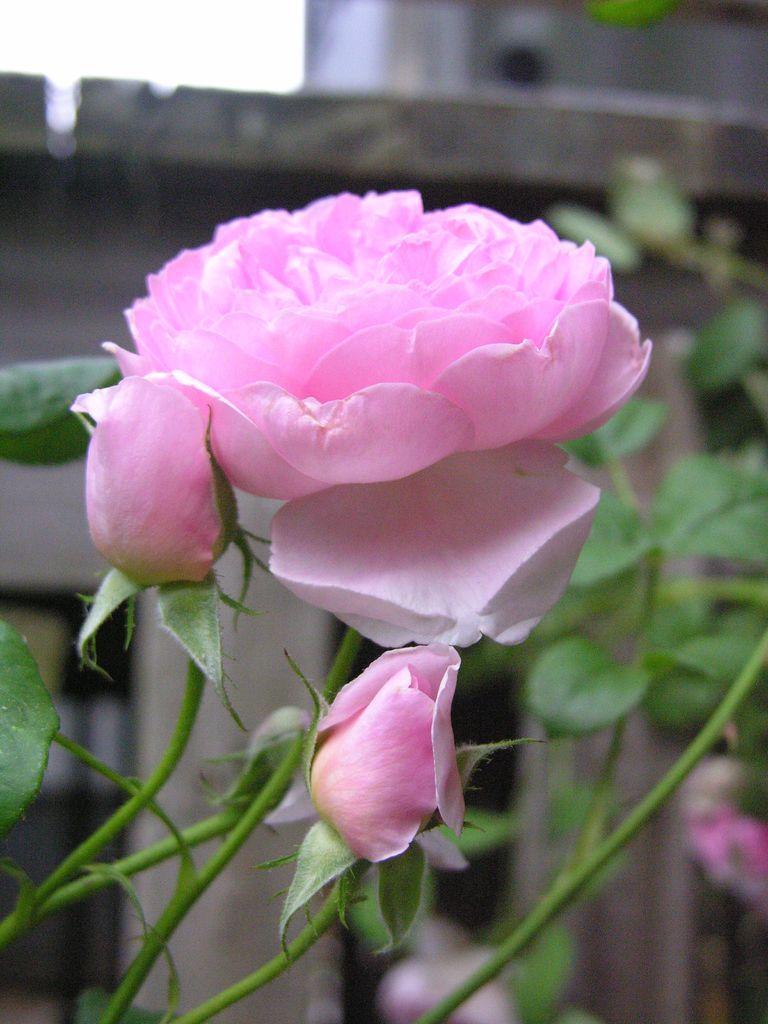Can you describe this image briefly? In this image I can see few pink colour flowers and green leaves. In the background I can see few more flowers, leaves, a building and I can see this image is little bit blurry in the background. 